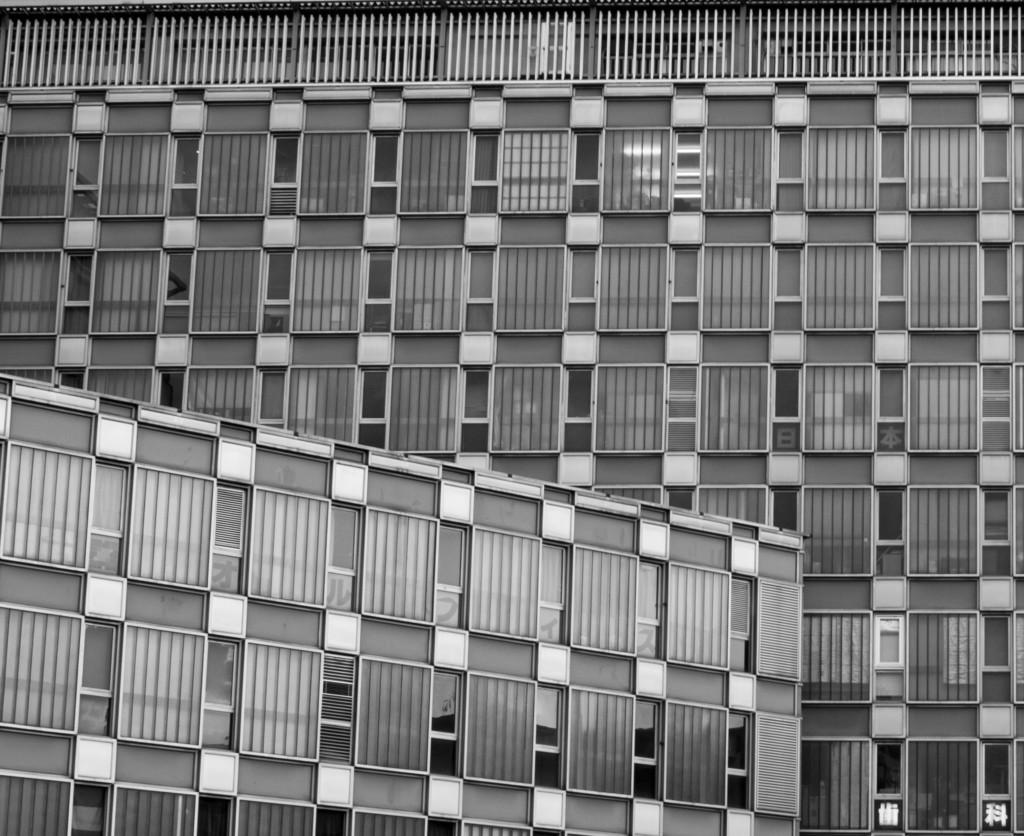What type of structure is visible in the image? There is a building in the image. How is the building depicted in the image? The building appears to be truncated. What architectural feature can be seen on the building? There are windows on the building. What type of experience can be gained from the roof of the building in the image? There is no roof visible in the image, as the building appears to be truncated. 